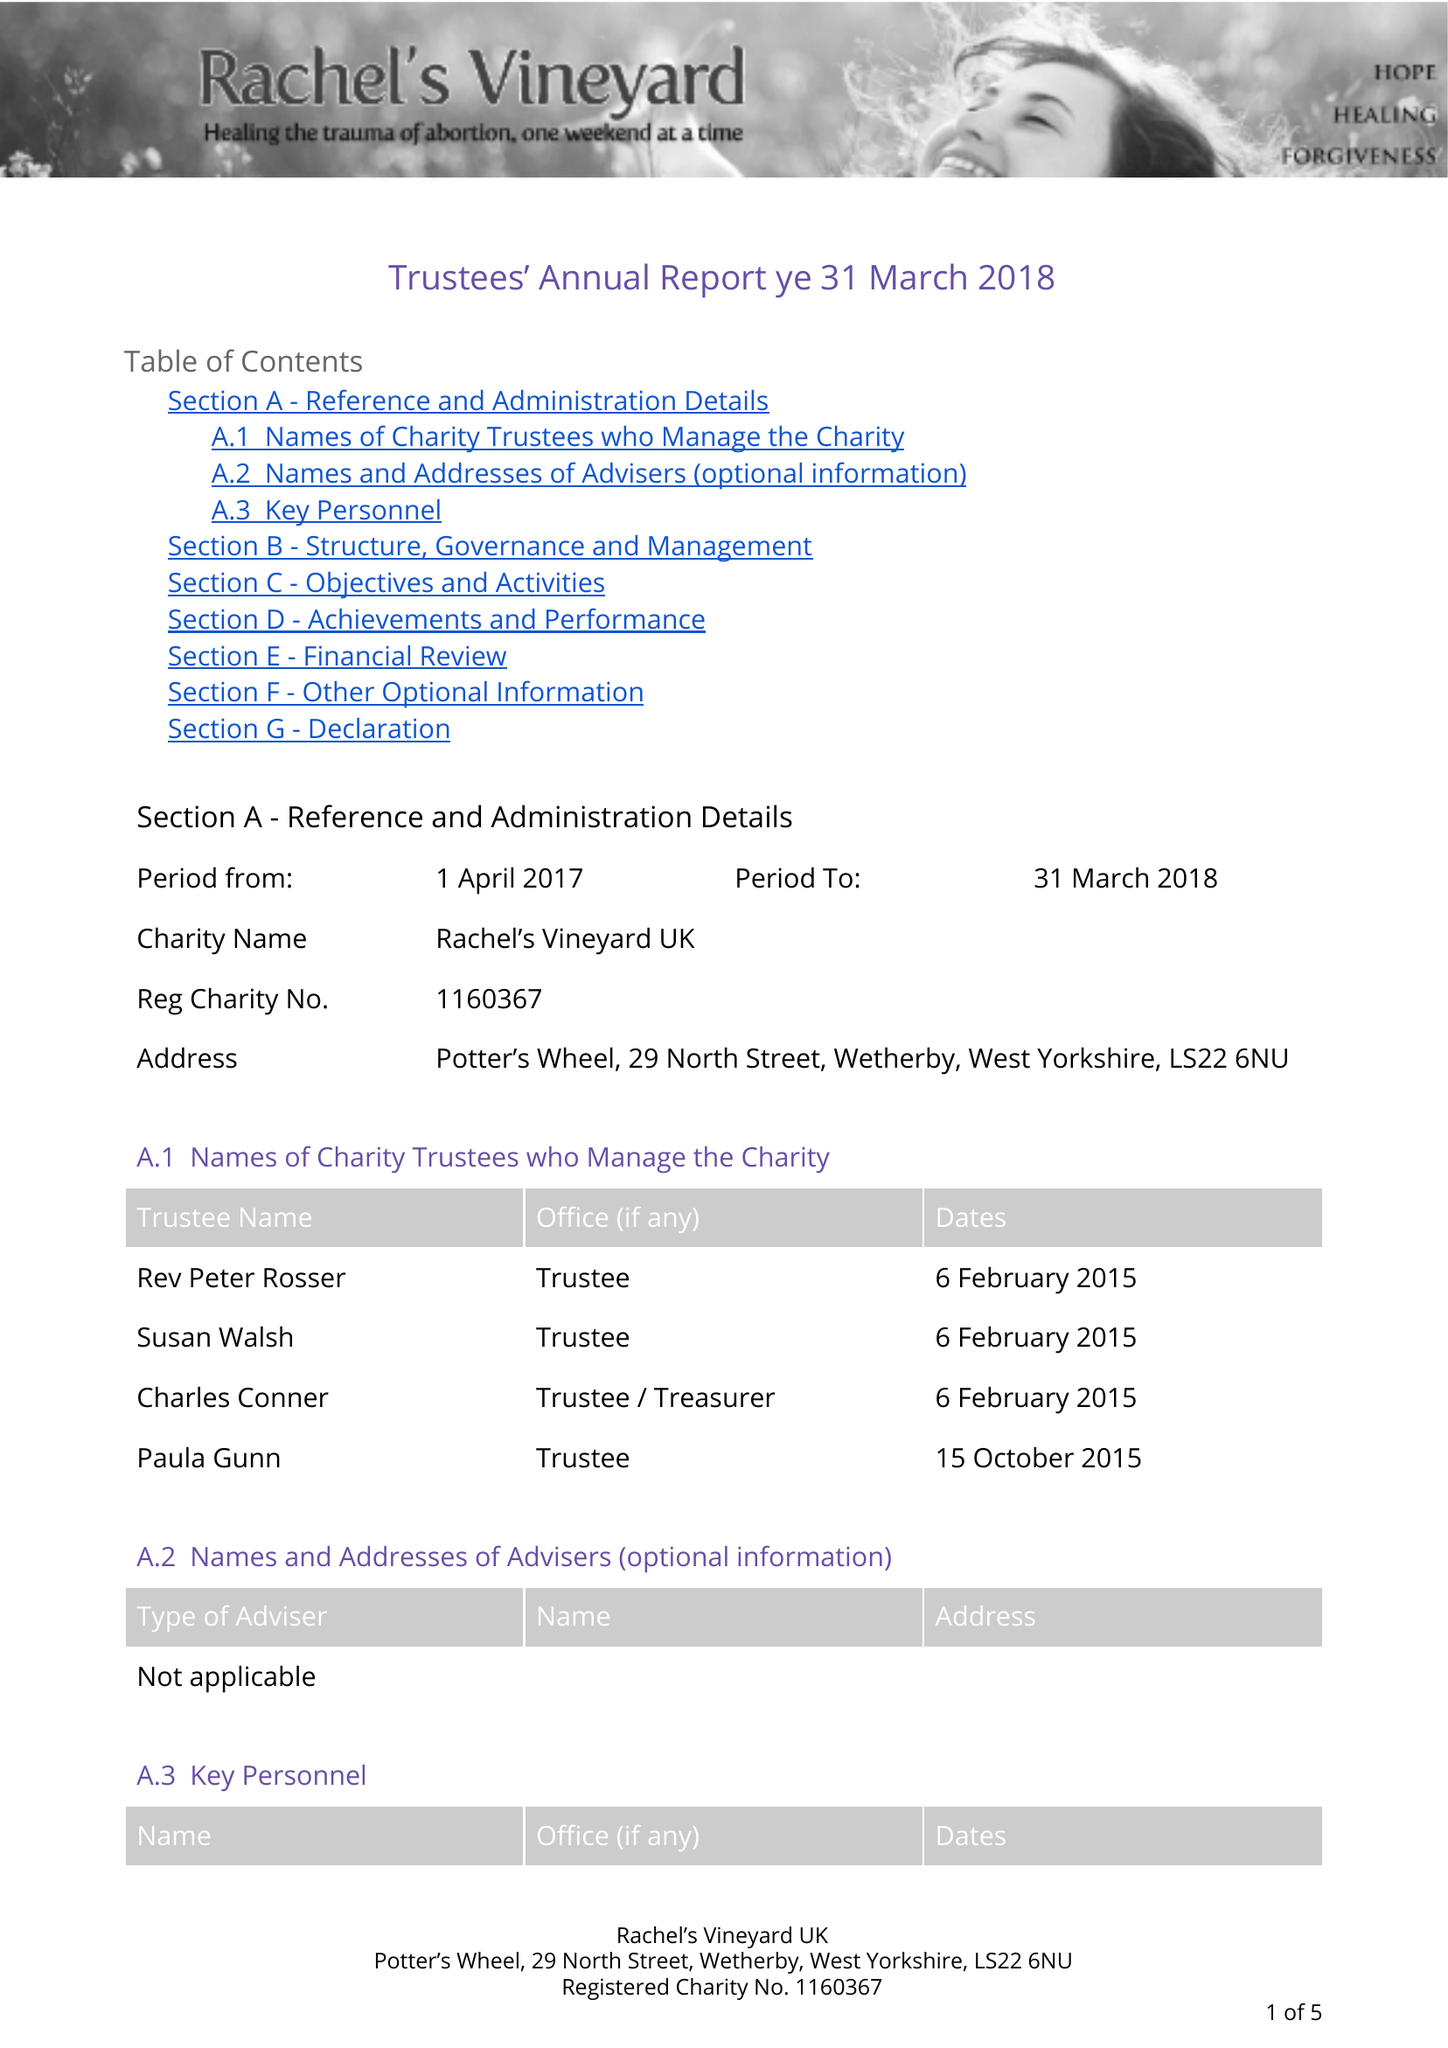What is the value for the address__street_line?
Answer the question using a single word or phrase. 29 NORTH STREET 